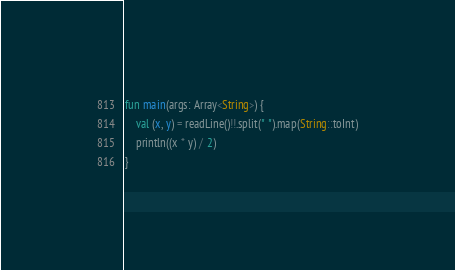Convert code to text. <code><loc_0><loc_0><loc_500><loc_500><_Kotlin_>fun main(args: Array<String>) {
    val (x, y) = readLine()!!.split(" ").map(String::toInt)
    println((x * y) / 2)
}</code> 